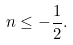<formula> <loc_0><loc_0><loc_500><loc_500>n \leq - \frac { 1 } { 2 } .</formula> 